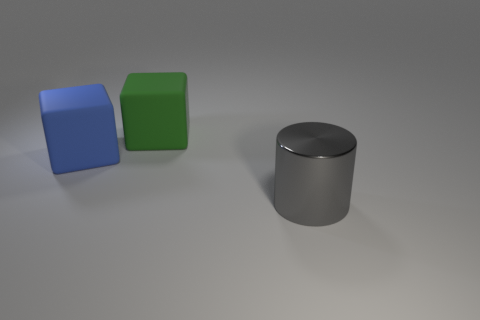Is there any other thing that is the same material as the large gray object?
Offer a terse response. No. Is the number of large brown metallic cubes greater than the number of cubes?
Your response must be concise. No. Are there any large blue objects that have the same material as the green object?
Make the answer very short. Yes. What shape is the thing that is both to the left of the big gray metal cylinder and on the right side of the blue rubber block?
Offer a very short reply. Cube. How many other things are the same shape as the blue thing?
Ensure brevity in your answer.  1. How many things are either big green cubes or matte things?
Keep it short and to the point. 2. What size is the gray metallic cylinder to the right of the blue object?
Provide a short and direct response. Large. What color is the large object that is in front of the large green matte object and to the right of the blue cube?
Your answer should be compact. Gray. Do the big thing on the left side of the green matte object and the big green block have the same material?
Ensure brevity in your answer.  Yes. Are there any large shiny things in front of the large shiny cylinder?
Provide a succinct answer. No. 